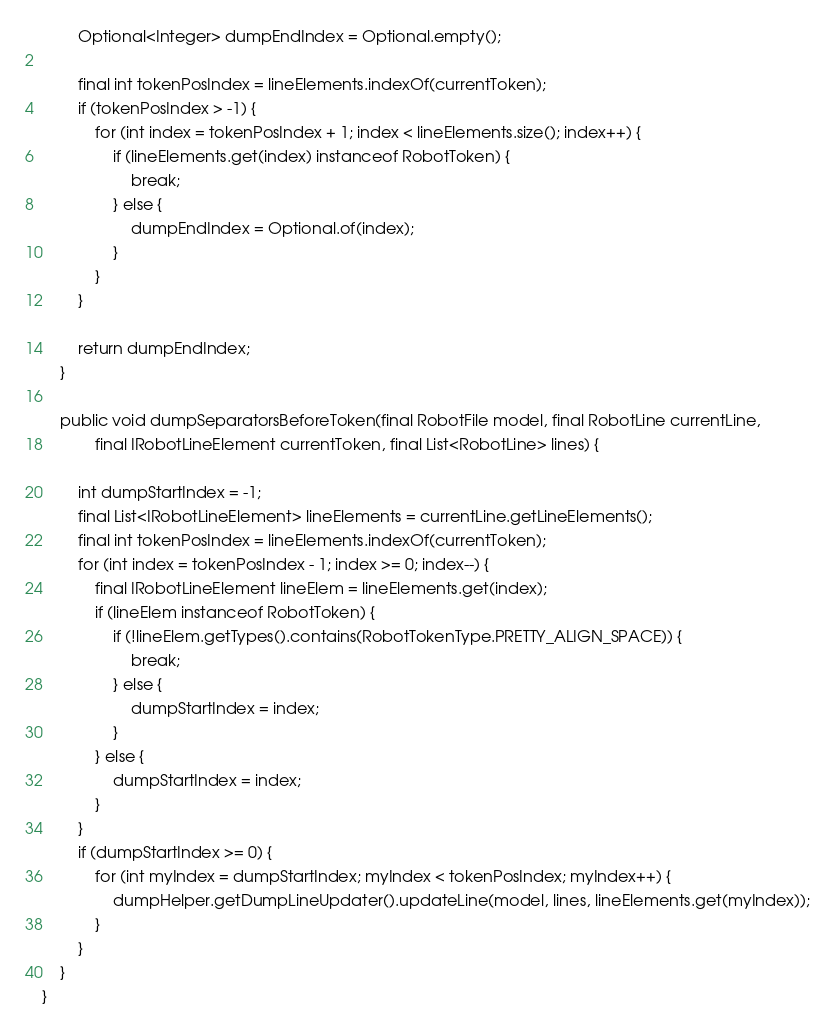Convert code to text. <code><loc_0><loc_0><loc_500><loc_500><_Java_>        Optional<Integer> dumpEndIndex = Optional.empty();

        final int tokenPosIndex = lineElements.indexOf(currentToken);
        if (tokenPosIndex > -1) {
            for (int index = tokenPosIndex + 1; index < lineElements.size(); index++) {
                if (lineElements.get(index) instanceof RobotToken) {
                    break;
                } else {
                    dumpEndIndex = Optional.of(index);
                }
            }
        }

        return dumpEndIndex;
    }

    public void dumpSeparatorsBeforeToken(final RobotFile model, final RobotLine currentLine,
            final IRobotLineElement currentToken, final List<RobotLine> lines) {

        int dumpStartIndex = -1;
        final List<IRobotLineElement> lineElements = currentLine.getLineElements();
        final int tokenPosIndex = lineElements.indexOf(currentToken);
        for (int index = tokenPosIndex - 1; index >= 0; index--) {
            final IRobotLineElement lineElem = lineElements.get(index);
            if (lineElem instanceof RobotToken) {
                if (!lineElem.getTypes().contains(RobotTokenType.PRETTY_ALIGN_SPACE)) {
                    break;
                } else {
                    dumpStartIndex = index;
                }
            } else {
                dumpStartIndex = index;
            }
        }
        if (dumpStartIndex >= 0) {
            for (int myIndex = dumpStartIndex; myIndex < tokenPosIndex; myIndex++) {
                dumpHelper.getDumpLineUpdater().updateLine(model, lines, lineElements.get(myIndex));
            }
        }
    }
}
</code> 